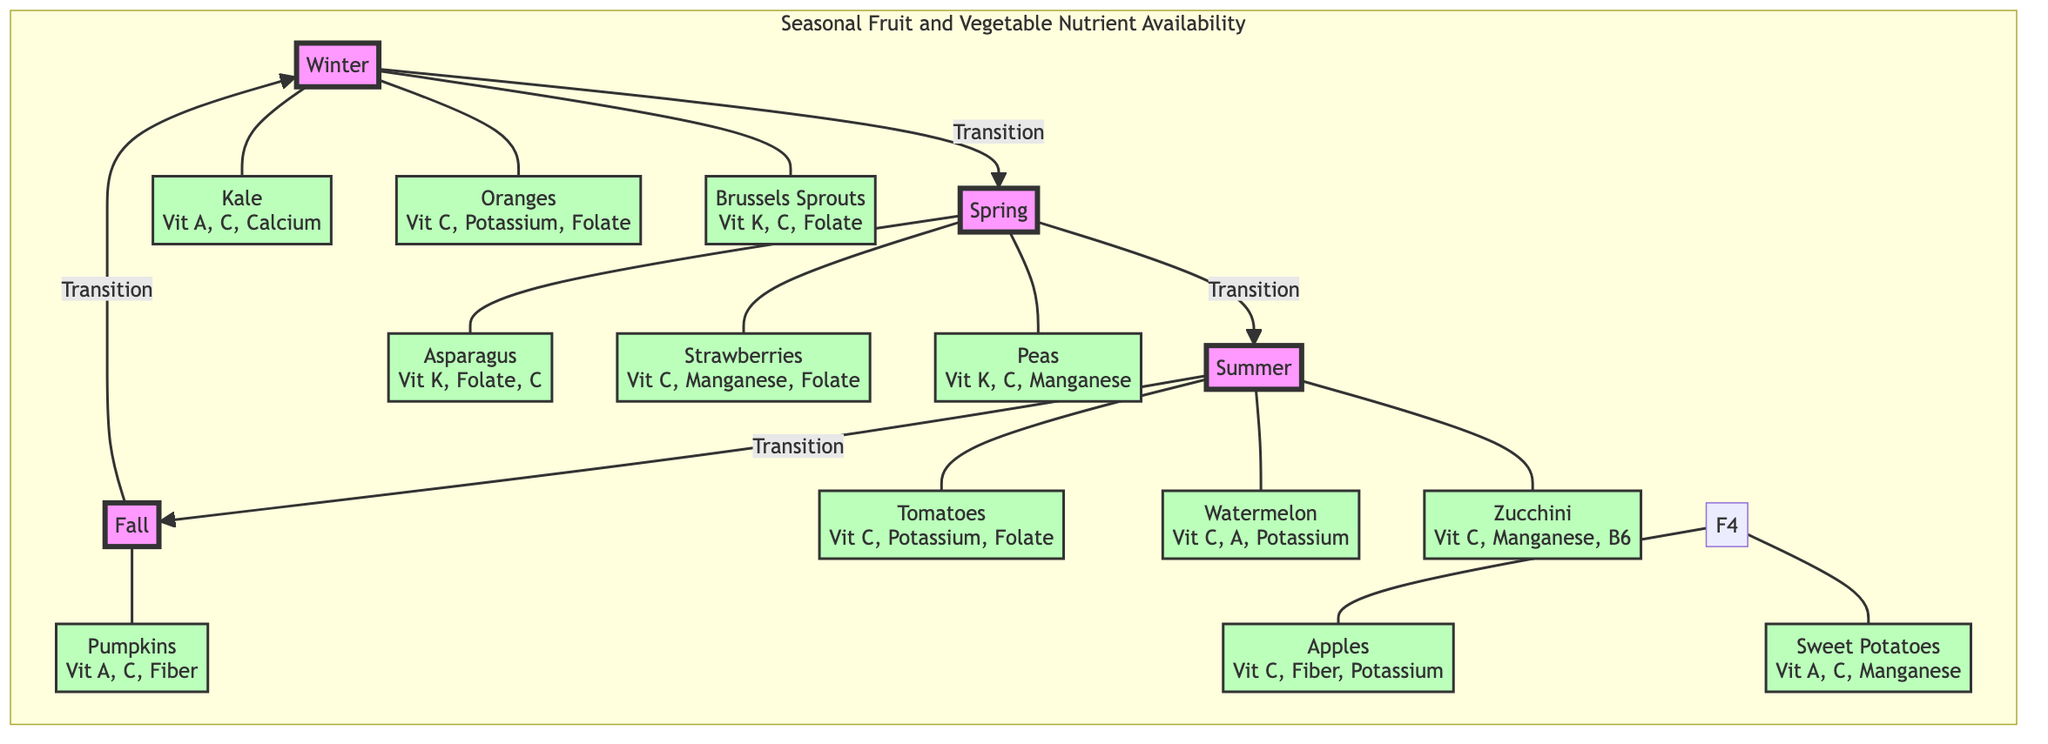What fruits are available in winter? The diagram shows three fruits available in winter: Kale, Oranges, and Brussels Sprouts. This information is extracted directly from the winter section (Q1) of the diagram.
Answer: Kale, Oranges, Brussels Sprouts Which vegetable contains the highest number of vitamins in spring? In the spring section (Q2), three produce items are listed: Asparagus, Strawberries, and Peas. Counting the vitamins noted: Asparagus (K, Folate, C), Strawberries (C, Manganese, Folate), and Peas (K, C, Manganese) shows each has three vitamins. Therefore, they are equal in nutrient content.
Answer: Asparagus, Strawberries, Peas How many fruits and vegetables are listed for summer? The summer section (Q3) of the diagram showcases three items: Tomatoes, Watermelon, and Zucchini. Counting these items leads to a total of three produce listed in summer.
Answer: 3 Which season features Sweet Potatoes? According to the diagram, Sweet Potatoes are categorized under the fall section (Q4). By locating the entry in the fall part of the circular diagram, we find that they are included there.
Answer: Fall What is the nutritional content of Oranges? In winter (Q1), the diagram specifies that Oranges contain Vitamin C, Potassium, and Folate. This information is explicitly stated next to Oranges in the diagram.
Answer: Vitamin C, Potassium, Folate Which two seasons contain vegetables rich in Vitamin K? The diagram indicates that Asparagus and Peas in spring (Q2) and Kale and Brussels Sprouts in winter (Q1) are vegetables rich in Vitamin K. Therefore, we can identify both winter and spring as the seasons featuring such vegetables.
Answer: Winter, Spring Which fruit has the least variety of nutrients listed? Referring to the diagram, Apples in fall (Q4) contain three nutrients: Vitamin C, Fiber, and Potassium. Other fruits have more than three nutrients listed. Thus, Apples have the least variety of nutrients among those presented.
Answer: Apples How does the nutrient availability transition between seasons? The diagram highlights that there is a transition between each seasonal section (Q1 to Q2, Q2 to Q3, Q3 to Q4, and Q4 back to Q1). This cyclical pattern indicates a continuous, flowing change in availability from one season to the next.
Answer: Cyclical transition What vitamins are present in Zucchini? From the summer section (Q3), it’s shown that Zucchini provides Vitamin C, Manganese, and B6. This is directly stated next to Zucchini in the diagram.
Answer: Vitamin C, Manganese, B6 